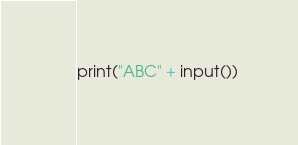Convert code to text. <code><loc_0><loc_0><loc_500><loc_500><_Python_>print("ABC" + input())</code> 